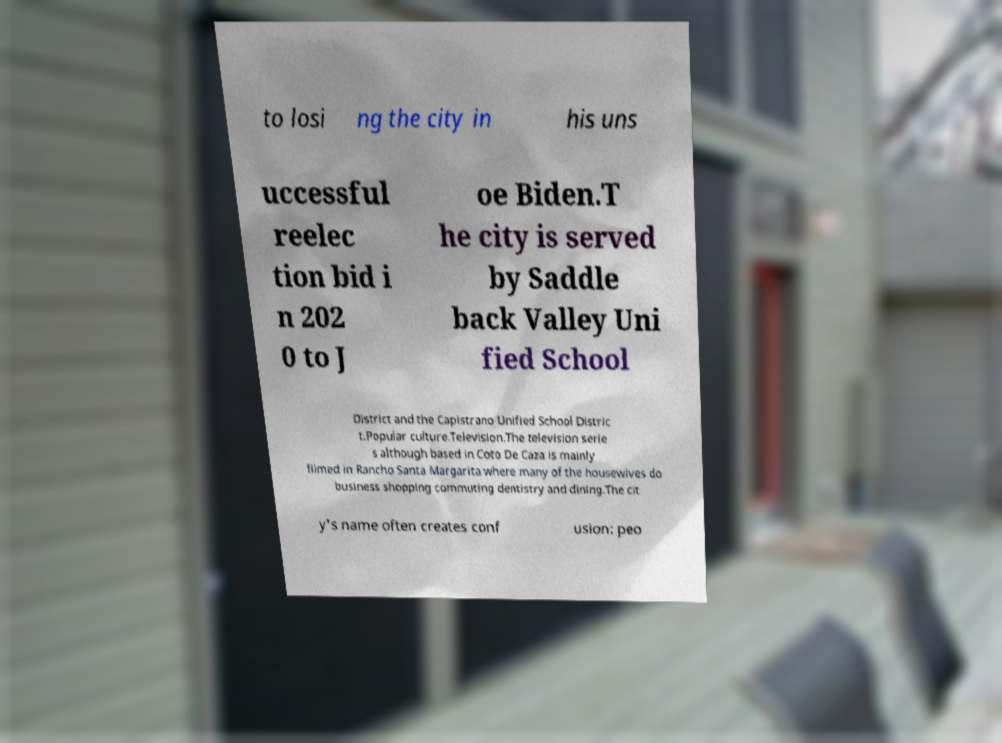Could you extract and type out the text from this image? to losi ng the city in his uns uccessful reelec tion bid i n 202 0 to J oe Biden.T he city is served by Saddle back Valley Uni fied School District and the Capistrano Unified School Distric t.Popular culture.Television.The television serie s although based in Coto De Caza is mainly filmed in Rancho Santa Margarita where many of the housewives do business shopping commuting dentistry and dining.The cit y's name often creates conf usion: peo 